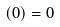Convert formula to latex. <formula><loc_0><loc_0><loc_500><loc_500>( 0 ) = 0</formula> 